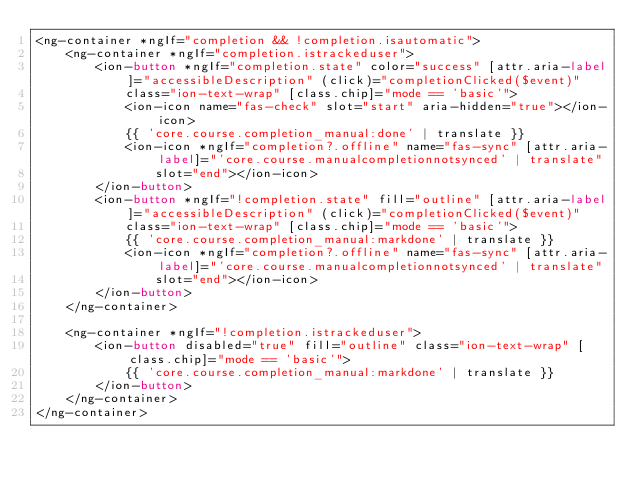Convert code to text. <code><loc_0><loc_0><loc_500><loc_500><_HTML_><ng-container *ngIf="completion && !completion.isautomatic">
    <ng-container *ngIf="completion.istrackeduser">
        <ion-button *ngIf="completion.state" color="success" [attr.aria-label]="accessibleDescription" (click)="completionClicked($event)"
            class="ion-text-wrap" [class.chip]="mode == 'basic'">
            <ion-icon name="fas-check" slot="start" aria-hidden="true"></ion-icon>
            {{ 'core.course.completion_manual:done' | translate }}
            <ion-icon *ngIf="completion?.offline" name="fas-sync" [attr.aria-label]="'core.course.manualcompletionnotsynced' | translate"
                slot="end"></ion-icon>
        </ion-button>
        <ion-button *ngIf="!completion.state" fill="outline" [attr.aria-label]="accessibleDescription" (click)="completionClicked($event)"
            class="ion-text-wrap" [class.chip]="mode == 'basic'">
            {{ 'core.course.completion_manual:markdone' | translate }}
            <ion-icon *ngIf="completion?.offline" name="fas-sync" [attr.aria-label]="'core.course.manualcompletionnotsynced' | translate"
                slot="end"></ion-icon>
        </ion-button>
    </ng-container>

    <ng-container *ngIf="!completion.istrackeduser">
        <ion-button disabled="true" fill="outline" class="ion-text-wrap" [class.chip]="mode == 'basic'">
            {{ 'core.course.completion_manual:markdone' | translate }}
        </ion-button>
    </ng-container>
</ng-container>
</code> 